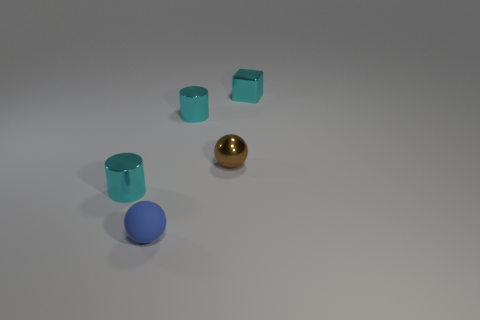What number of other objects are the same shape as the brown metallic thing?
Give a very brief answer. 1. Are there any other things that have the same material as the blue ball?
Ensure brevity in your answer.  No. What number of large things are either cylinders or blue spheres?
Ensure brevity in your answer.  0. There is a small blue matte thing in front of the tiny brown metallic ball; is its shape the same as the tiny brown thing behind the rubber sphere?
Make the answer very short. Yes. What size is the shiny cylinder that is behind the ball behind the tiny cyan thing that is to the left of the blue thing?
Offer a very short reply. Small. What is the size of the cylinder that is left of the blue matte sphere?
Provide a short and direct response. Small. What material is the cyan object in front of the tiny brown shiny ball?
Keep it short and to the point. Metal. What number of cyan things are shiny cubes or tiny cylinders?
Keep it short and to the point. 3. Is the tiny brown object made of the same material as the sphere left of the small brown shiny sphere?
Offer a terse response. No. Are there an equal number of balls that are behind the small block and brown metallic objects that are right of the brown metallic object?
Keep it short and to the point. Yes. 